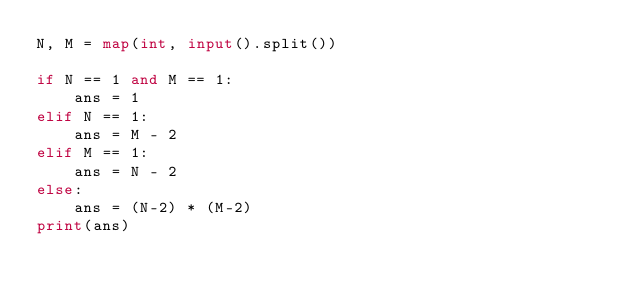<code> <loc_0><loc_0><loc_500><loc_500><_Python_>N, M = map(int, input().split())

if N == 1 and M == 1:
    ans = 1
elif N == 1:
    ans = M - 2
elif M == 1:
    ans = N - 2
else:
    ans = (N-2) * (M-2)
print(ans)
</code> 